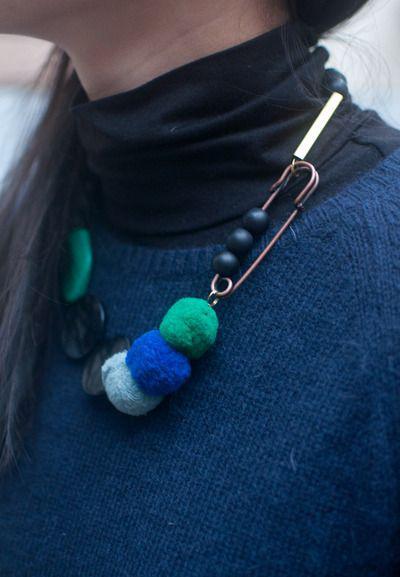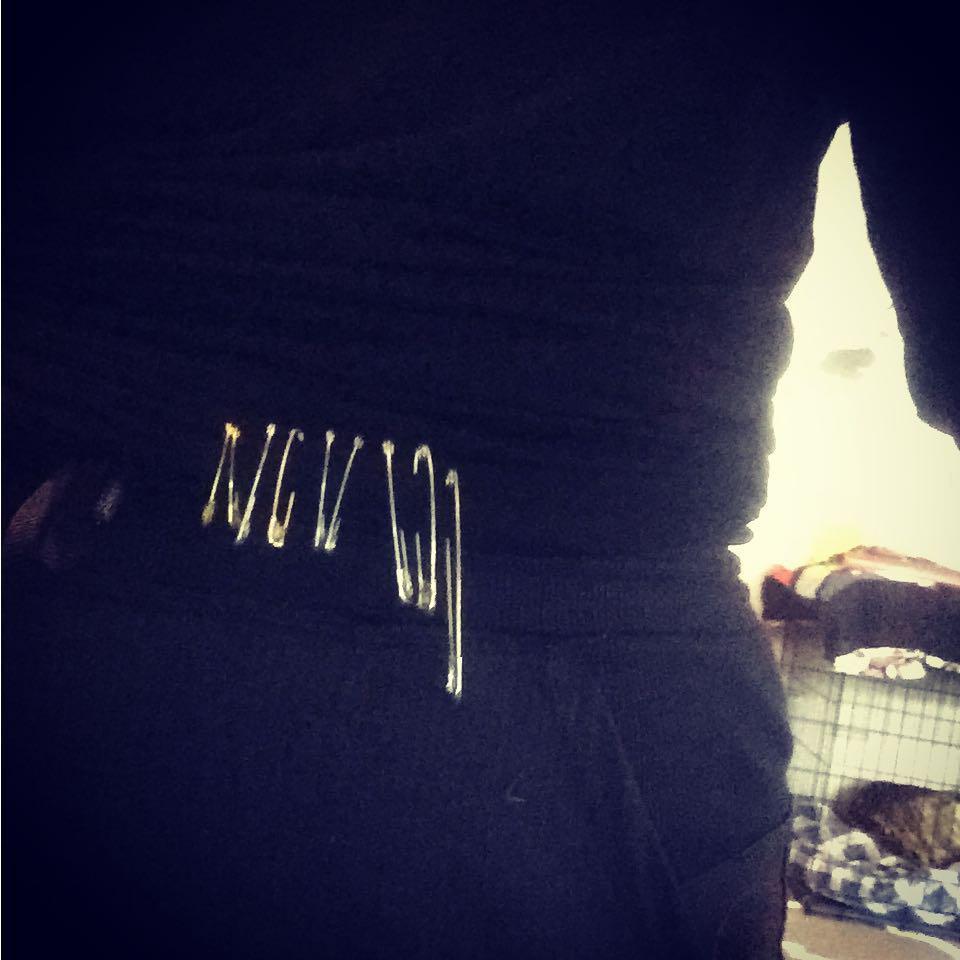The first image is the image on the left, the second image is the image on the right. For the images displayed, is the sentence "An image shows a necklace designed to include at least one safety pin." factually correct? Answer yes or no. Yes. 